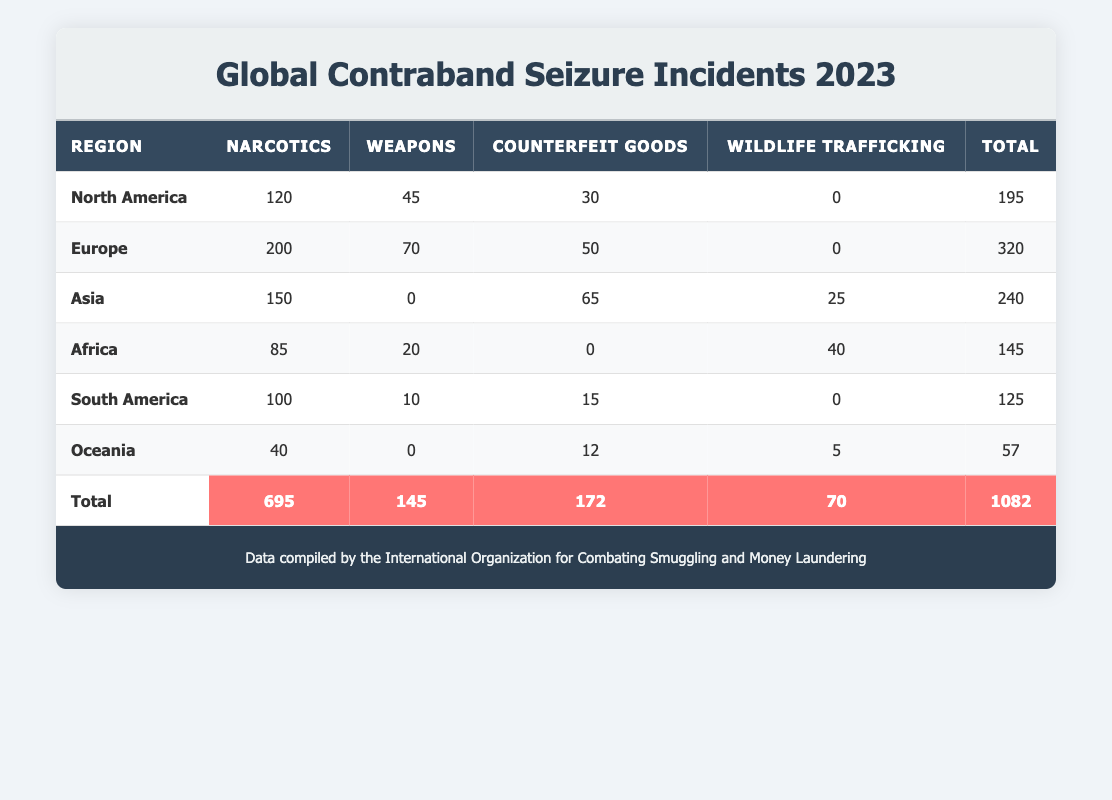What region had the highest number of narcotics seizure incidents in 2023? According to the table, Europe has the highest number of narcotics seizure incidents with a total of 200 incidents.
Answer: Europe How many total seizure incidents were reported for South America? In the table, the total for South America is the sum of narcotics (100), weapons (10), and counterfeit goods (15), which equals 125 incidents.
Answer: 125 Is it true that Africa reported more incidents of wildlife trafficking than North America? The table shows that Africa reported 40 incidents of wildlife trafficking, while North America reported 0 incidents, making the statement true.
Answer: Yes What is the difference in the total number of seizures between Asia and Africa? Asia reported a total of 240 seizure incidents compared to Africa’s 145. The difference is calculated as 240 - 145 = 95.
Answer: 95 Which type of seizure incident was most prevalent in North America? The table indicates that the most prevalent type of seizure incident in North America is narcotics, with 120 incidents.
Answer: Narcotics What is the average number of weapons seizure incidents across all regions in 2023? The total number of weapons seizures is 145, with four regions reporting these incidents: North America (45), Europe (70), Africa (20), and South America (10). The average is calculated as 145 / 4 = 36.25.
Answer: 36.25 Which region had the lowest total number of seizure incidents and what was that total? From the table, Oceania had the lowest total number of seizure incidents with a total of 57 (narcotics 40, counterfeit goods 12, wildlife trafficking 5).
Answer: 57 How many more incidents of counterfeit goods were seized in Europe compared to South America? Europe reported 50 incidents of counterfeit goods while South America reported 15. The difference is 50 - 15 = 35 incidents more in Europe.
Answer: 35 If we consider all seizure types, which region had the highest total and what is the total number? The highest total across all seizure types is from Europe with a total of 320 incidents.
Answer: 320 